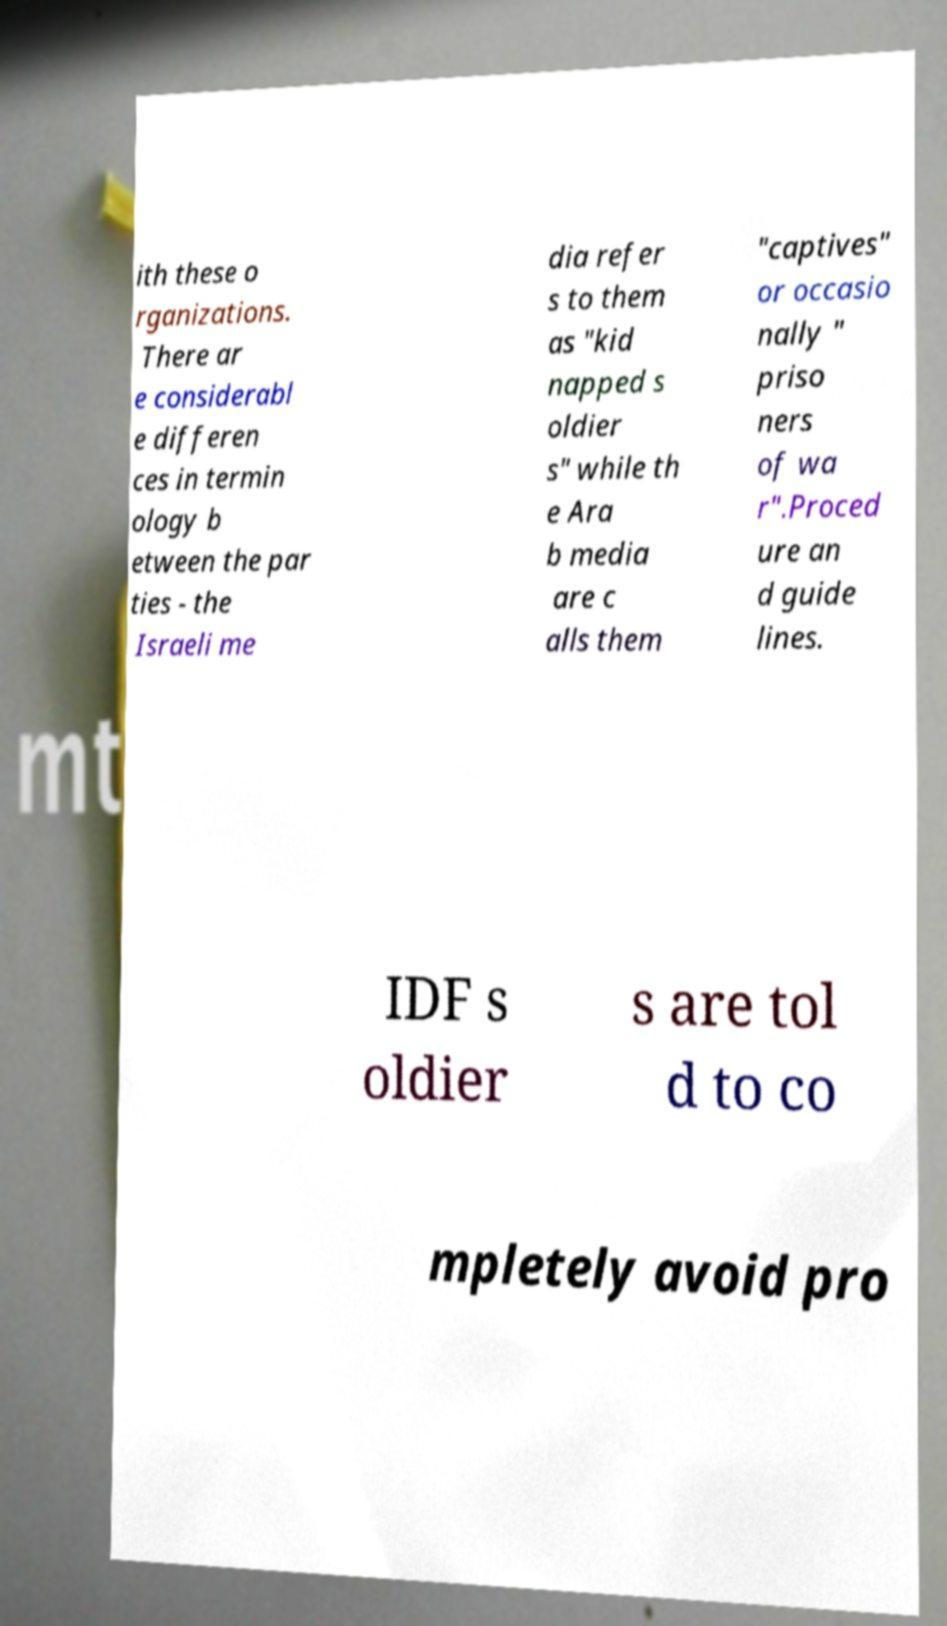Could you assist in decoding the text presented in this image and type it out clearly? ith these o rganizations. There ar e considerabl e differen ces in termin ology b etween the par ties - the Israeli me dia refer s to them as "kid napped s oldier s" while th e Ara b media are c alls them "captives" or occasio nally " priso ners of wa r".Proced ure an d guide lines. IDF s oldier s are tol d to co mpletely avoid pro 